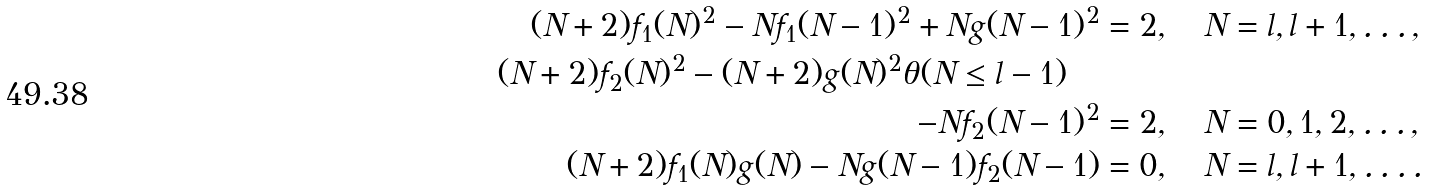<formula> <loc_0><loc_0><loc_500><loc_500>( N + 2 ) f _ { 1 } ( N ) ^ { 2 } - N f _ { 1 } ( N - 1 ) ^ { 2 } + N g ( N - 1 ) ^ { 2 } & = 2 , \quad N = l , l + 1 , \dots , \\ ( N + 2 ) f _ { 2 } ( N ) ^ { 2 } - ( N + 2 ) g ( N ) ^ { 2 } \theta ( N \leq l - 1 ) \quad & \\ - N f _ { 2 } ( N - 1 ) ^ { 2 } & = 2 , \quad N = 0 , 1 , 2 , \dots , \\ ( N + 2 ) f _ { 1 } ( N ) g ( N ) - N g ( N - 1 ) f _ { 2 } ( N - 1 ) & = 0 , \quad N = l , l + 1 , \dots .</formula> 